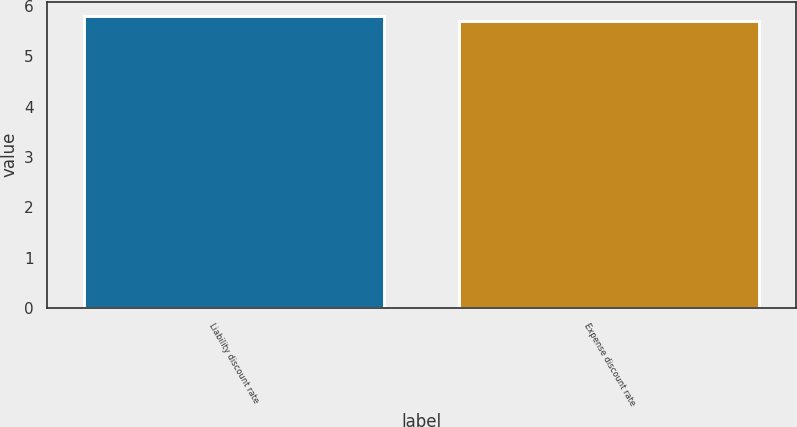Convert chart to OTSL. <chart><loc_0><loc_0><loc_500><loc_500><bar_chart><fcel>Liability discount rate<fcel>Expense discount rate<nl><fcel>5.8<fcel>5.7<nl></chart> 